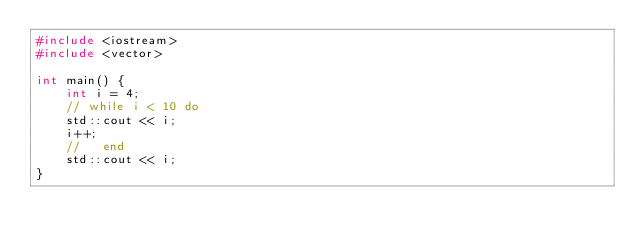<code> <loc_0><loc_0><loc_500><loc_500><_C++_>#include <iostream>
#include <vector>

int main() {
    int i = 4;
    // while i < 10 do 
    std::cout << i;
    i++;
    //   end 
    std::cout << i;
}

</code> 